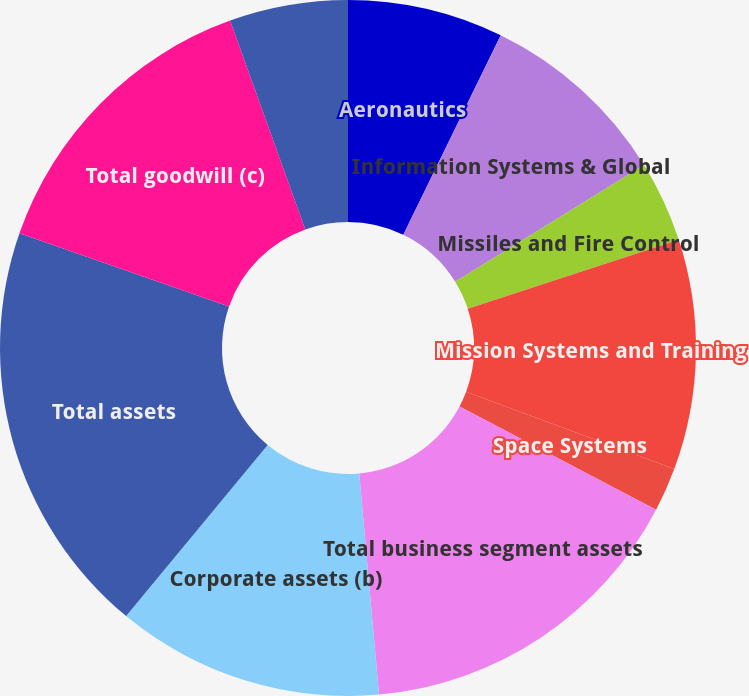Convert chart. <chart><loc_0><loc_0><loc_500><loc_500><pie_chart><fcel>Aeronautics<fcel>Information Systems & Global<fcel>Missiles and Fire Control<fcel>Mission Systems and Training<fcel>Space Systems<fcel>Total business segment assets<fcel>Corporate assets (b)<fcel>Total assets<fcel>Total goodwill (c)<fcel>Total customer advances and<nl><fcel>7.23%<fcel>8.96%<fcel>3.77%<fcel>10.69%<fcel>2.04%<fcel>15.88%<fcel>12.42%<fcel>19.34%<fcel>14.15%<fcel>5.5%<nl></chart> 